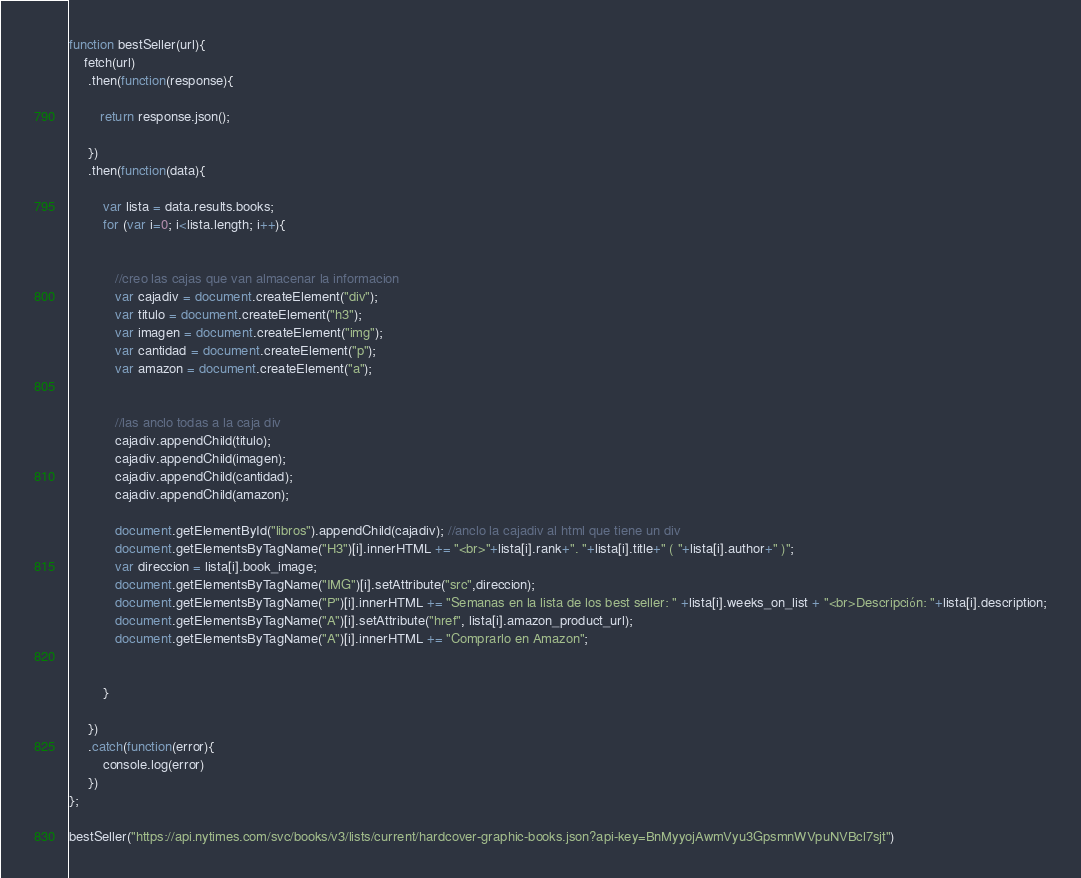<code> <loc_0><loc_0><loc_500><loc_500><_JavaScript_>function bestSeller(url){
    fetch(url)
     .then(function(response){
         
        return response.json();

     })
     .then(function(data){
         
         var lista = data.results.books;
         for (var i=0; i<lista.length; i++){
            

            //creo las cajas que van almacenar la informacion
            var cajadiv = document.createElement("div"); 
            var titulo = document.createElement("h3");
            var imagen = document.createElement("img");
            var cantidad = document.createElement("p");
            var amazon = document.createElement("a");
            

            //las anclo todas a la caja div
            cajadiv.appendChild(titulo);
            cajadiv.appendChild(imagen);
            cajadiv.appendChild(cantidad);
            cajadiv.appendChild(amazon);
            
            document.getElementById("libros").appendChild(cajadiv); //anclo la cajadiv al html que tiene un div
            document.getElementsByTagName("H3")[i].innerHTML += "<br>"+lista[i].rank+". "+lista[i].title+" ( "+lista[i].author+" )";
            var direccion = lista[i].book_image;
            document.getElementsByTagName("IMG")[i].setAttribute("src",direccion);
            document.getElementsByTagName("P")[i].innerHTML += "Semanas en la lista de los best seller: " +lista[i].weeks_on_list + "<br>Descripción: "+lista[i].description;
            document.getElementsByTagName("A")[i].setAttribute("href", lista[i].amazon_product_url);
            document.getElementsByTagName("A")[i].innerHTML += "Comprarlo en Amazon";


         }

     })
     .catch(function(error){
         console.log(error)
     })
};

bestSeller("https://api.nytimes.com/svc/books/v3/lists/current/hardcover-graphic-books.json?api-key=BnMyyojAwmVyu3GpsmnWVpuNVBcl7sjt")</code> 